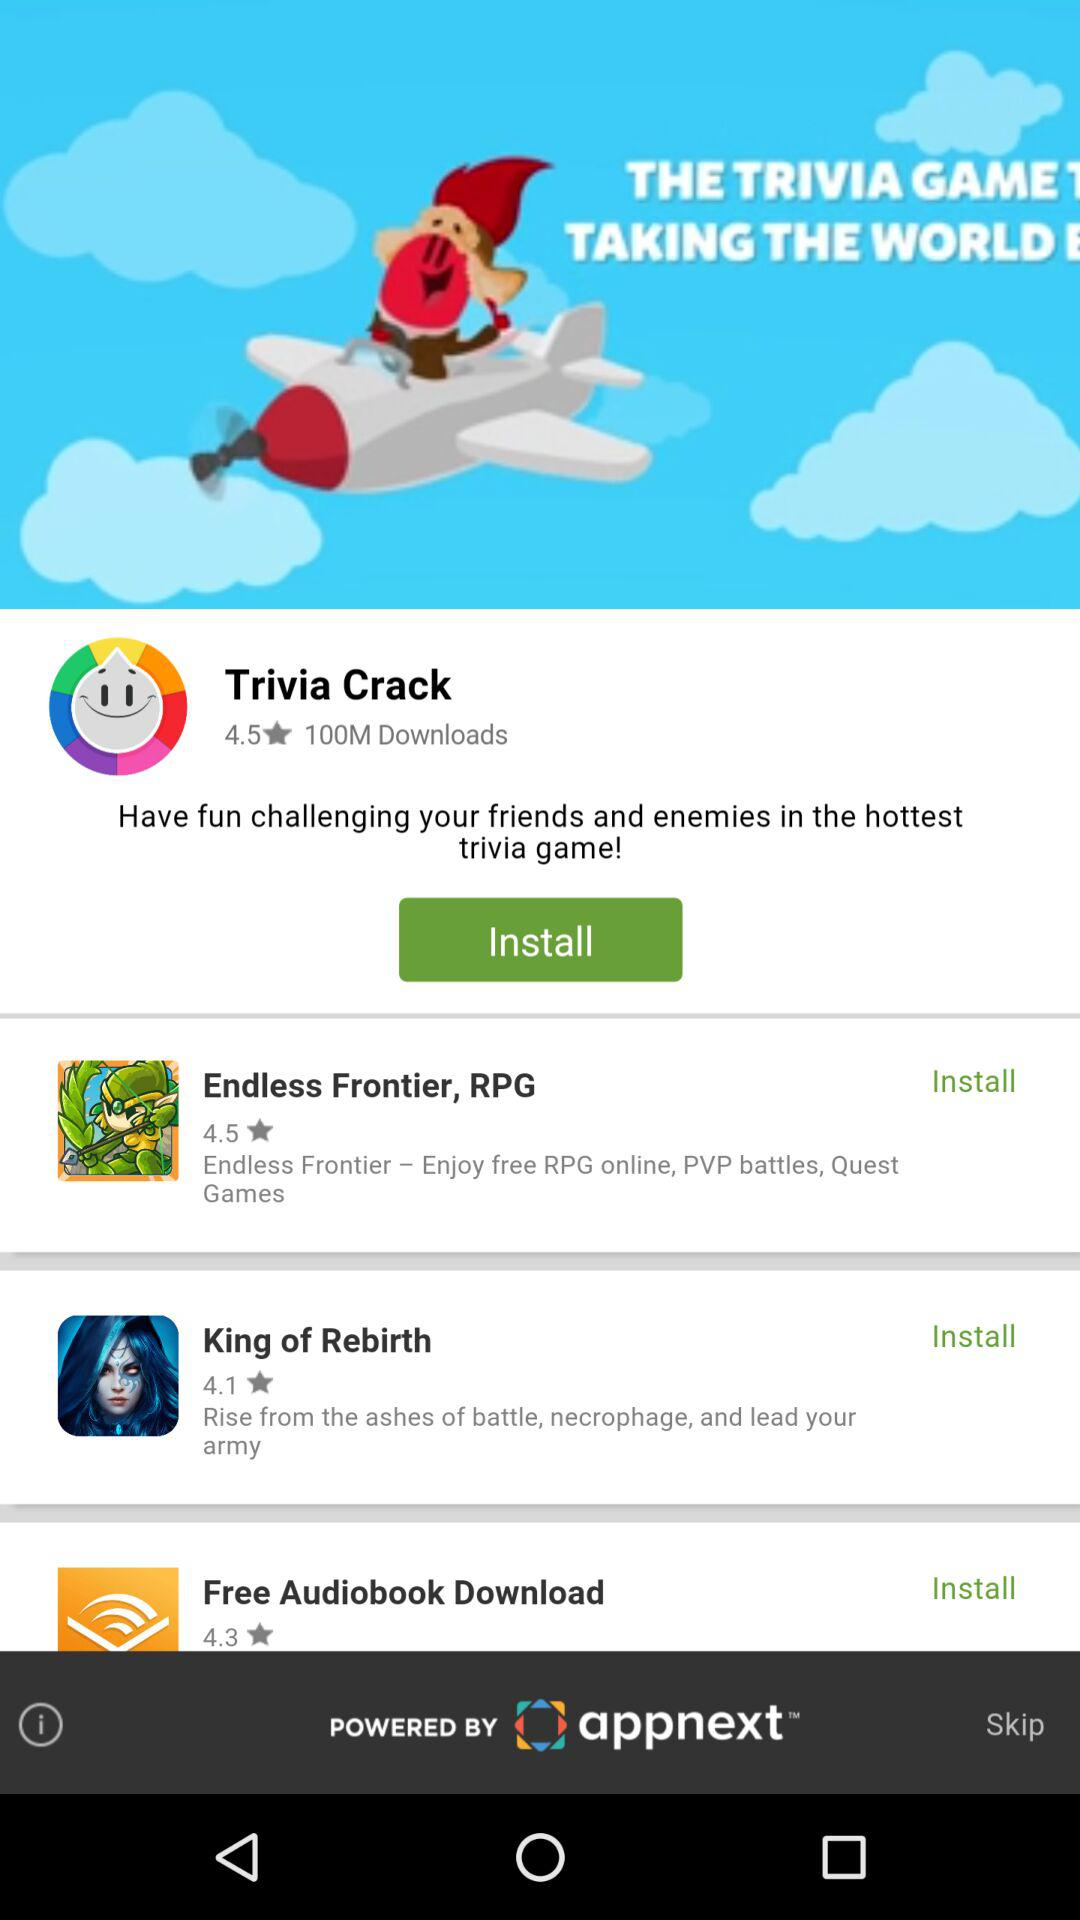Which game has a 4.5 rating? The game is "Endless Frontier, RPG". 